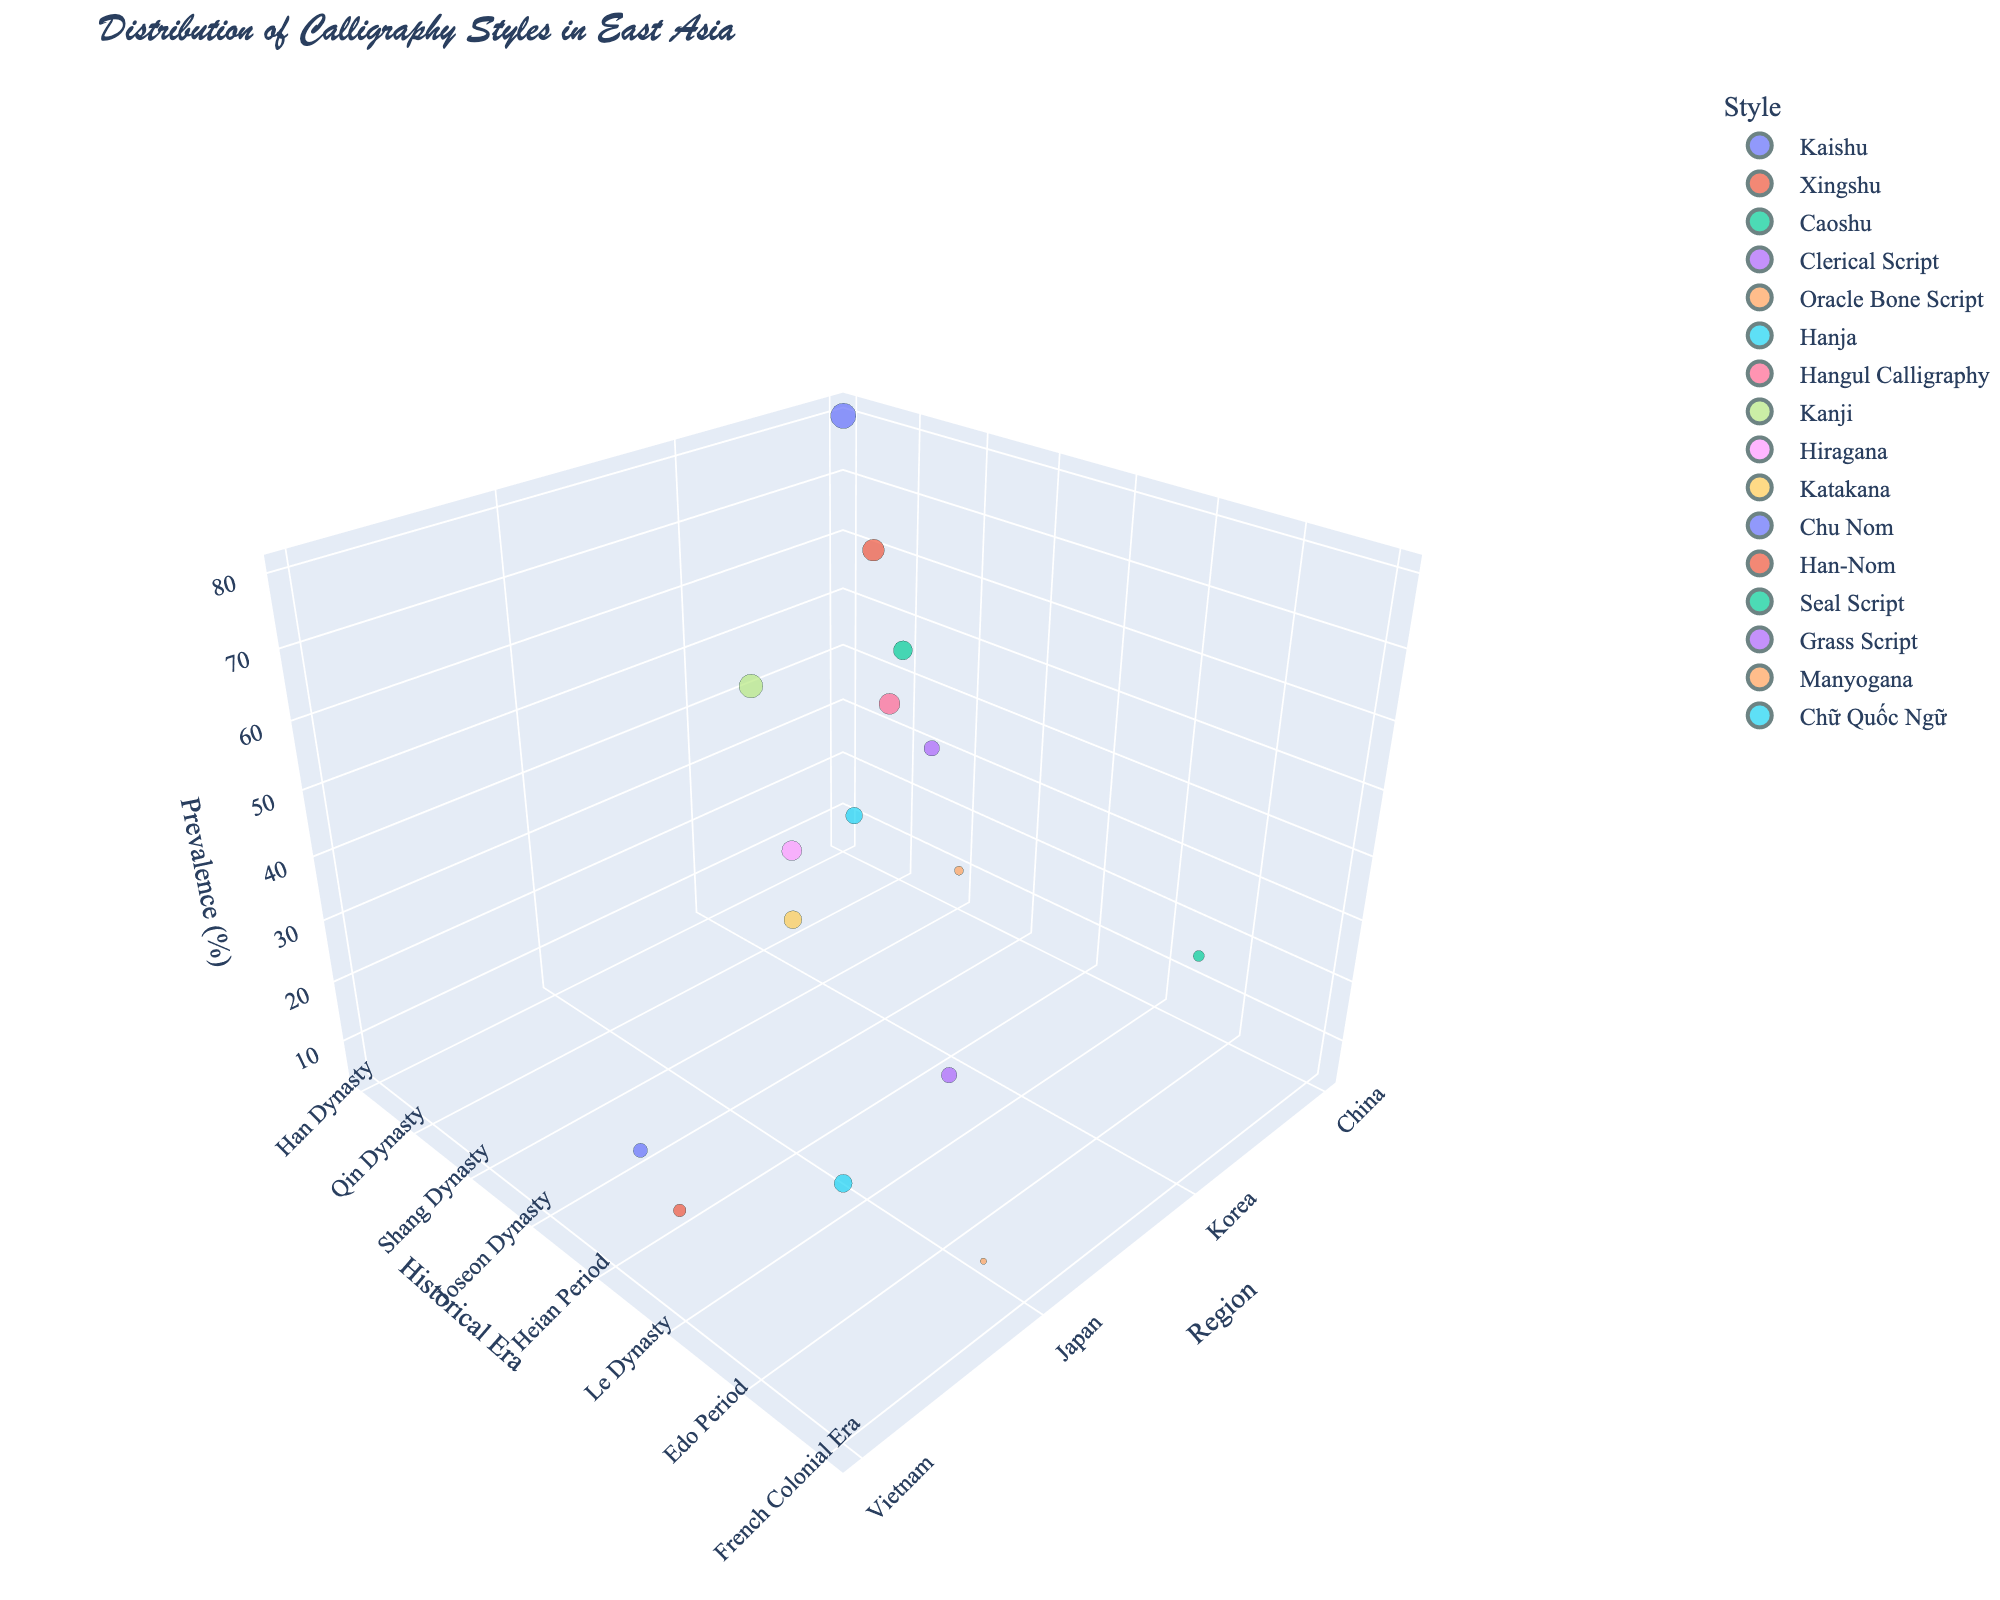what is the title of the chart? The title appears at the top of the figure in large, prominent text. The title is "Distribution of Calligraphy Styles in East Asia"
Answer: Distribution of Calligraphy Styles in East Asia What region has the highest prevalence of calligraphy styles? By observing the z-axis (Prevalence) with the x-axis (Region), we can see that "China" has the highest data points with larger bubble sizes, indicating higher prevalence.
Answer: China Count the number of calligraphy styles represented in this chart. Each bubble represents a different style, and by counting each individual bubble, we get a total of 16 styles.
Answer: 16 Which calligraphy style has the smallest prevalence, and what is its historical era? By finding the smallest bubble in the 3D chart and checking its details, we see that "Manyogana" has the smallest prevalence of 5, originating from the Asuka Period.
Answer: Manyogana, Asuka Period Compare prevalence between Kaishu and Hangul Calligraphy. Which is higher, and by how much? Kaishu has a prevalence of 80, and Hangul Calligraphy has a prevalence of 55. The difference is 80 - 55 = 25. Thus, Kaishu is higher by 25.
Answer: Kaishu is higher by 25 What is the historical influence of Hangul Calligraphy and how does its prevalence compare to Katakana? Hangul Calligraphy originates from the Joseon Dynasty with a prevalence of 55. Katakana, from the Heian Period, has a prevalence of 40. Comparing the two, Hangul Calligraphy has a higher prevalence.
Answer: Hangul Calligraphy has a higher prevalence Average the prevalence of calligraphy styles from Vietnam. Vietnam has the following prevalence values: 25 (Chu Nom), 20 (Han-Nom), and 40 (Chữ Quốc Ngữ). (25 + 20 + 40) / 3 = 85 / 3 ≈ 28.3.
Answer: ≈ 28.3 Identify which dynasty has the highest representation of calligraphy styles. By counting the number of unique dynasties across the different regions, we see that the "Heian Period" appears twice: Hiragana and Katakana in Japan. Therefore, the Heian Period has the highest representation.
Answer: Heian Period Chose any two Japanese calligraphy styles and compare their historical eras. Comparing "Hiragana" (Heian Period) and "Grass Script" (Edo Period), Hiragana is older as the Heian Period precedes the Edo Period.
Answer: Hiragana is older Which style originating from China during the Zhou Dynasty, and what is its prevalence? The figure shows that "Seal Script" originates from the Zhou Dynasty with a prevalence of 15.
Answer: Seal Script, 15 